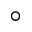Convert formula to latex. <formula><loc_0><loc_0><loc_500><loc_500>^ { \circ }</formula> 